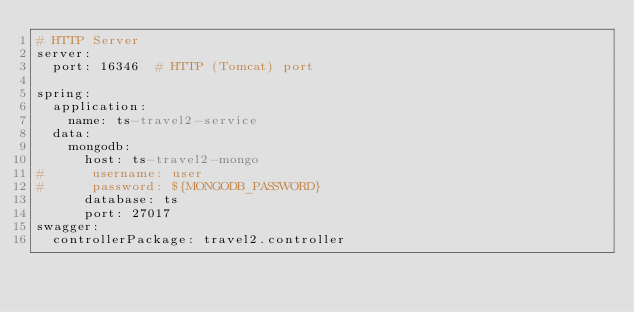<code> <loc_0><loc_0><loc_500><loc_500><_YAML_># HTTP Server
server:
  port: 16346  # HTTP (Tomcat) port

spring:
  application:
    name: ts-travel2-service
  data:
    mongodb:
      host: ts-travel2-mongo
#      username: user
#      password: ${MONGODB_PASSWORD}
      database: ts
      port: 27017
swagger:
  controllerPackage: travel2.controller</code> 